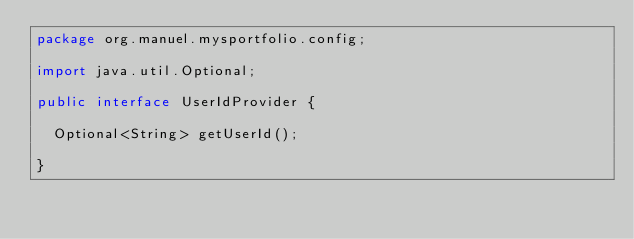Convert code to text. <code><loc_0><loc_0><loc_500><loc_500><_Java_>package org.manuel.mysportfolio.config;

import java.util.Optional;

public interface UserIdProvider {

  Optional<String> getUserId();

}
</code> 